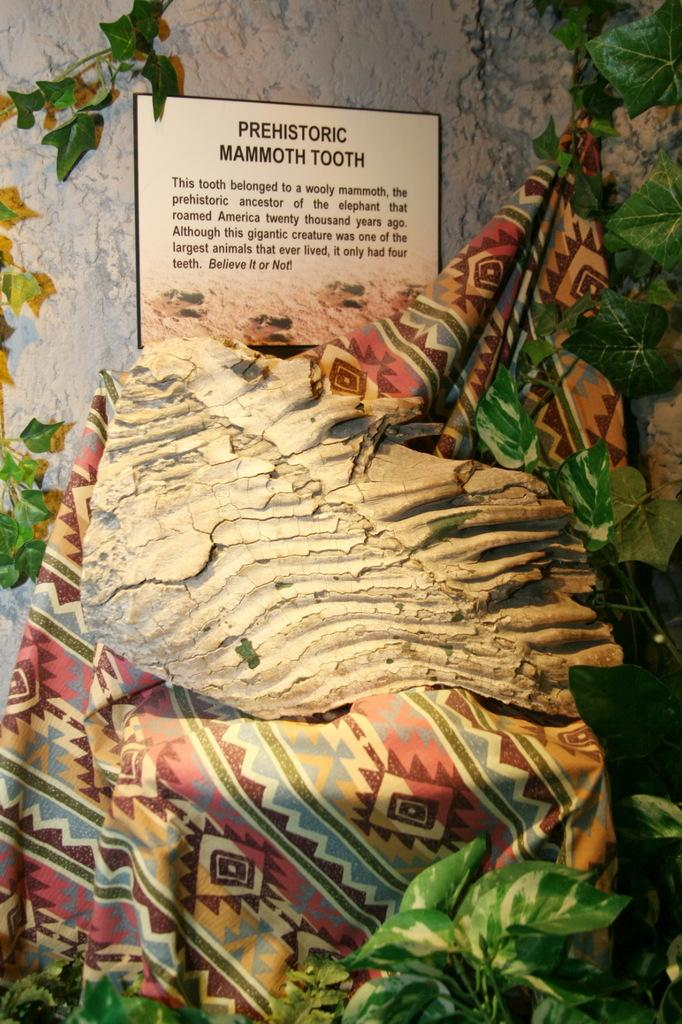<image>
Present a compact description of the photo's key features. A museum exhibit that says PREHISTORIC MAMMOTH TOOTH and some more text. 